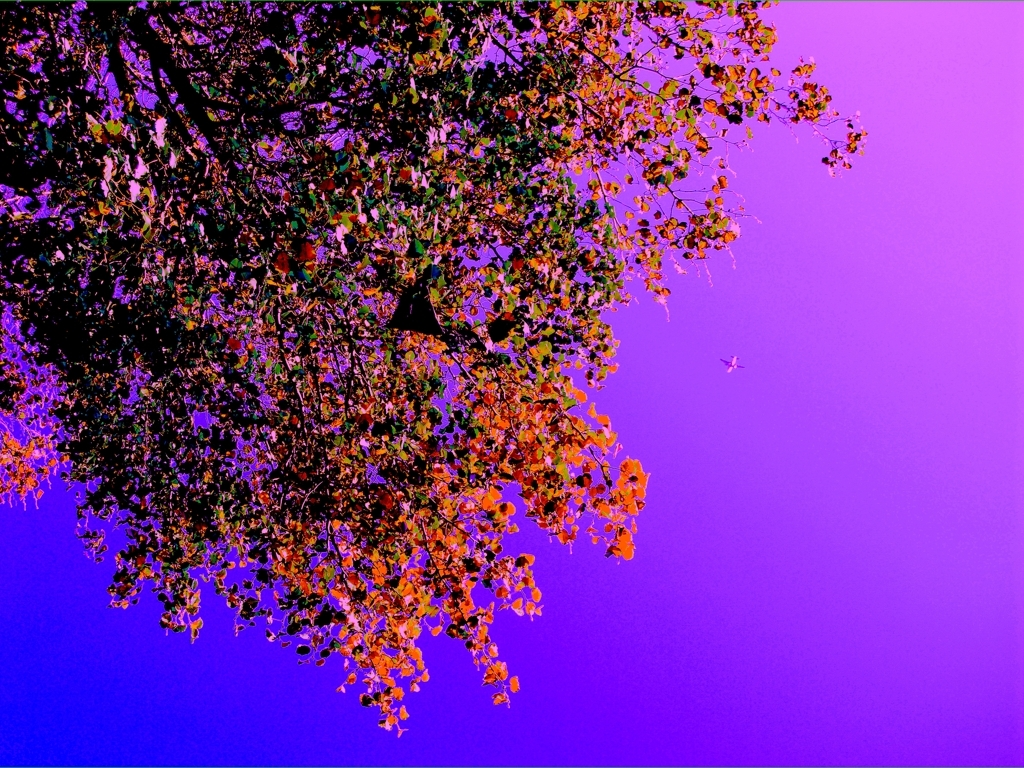Is the image free from any quality issues? The image displays a vibrant contrast of colors with a focus on the silhouette of a tree against a purple sky. The quality seems intentionally altered for artistic effect; there are no unintentional quality issues such as blurriness or pixelation. 